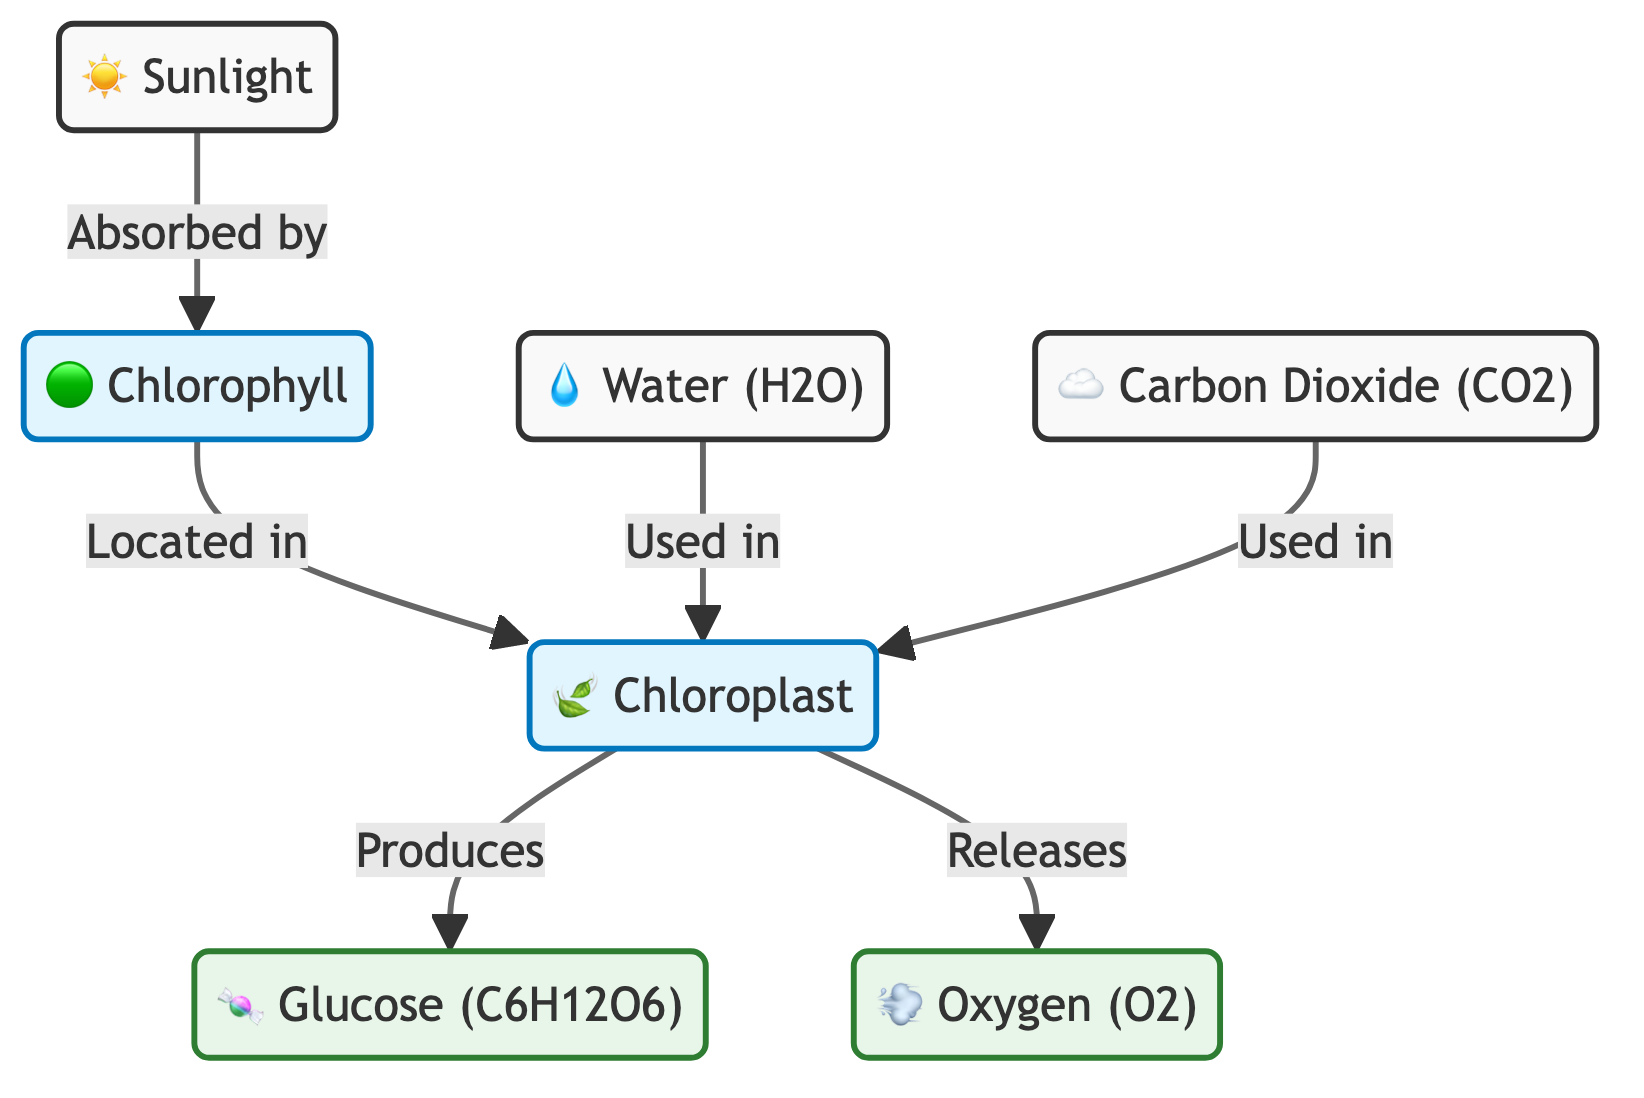What is produced in the chloroplast? The diagram states that the chloroplast produces glucose and releases oxygen, indicating that these are the outputs of the chloroplast. The term "produces" leads directly to "glucose" as one of the products.
Answer: Glucose Where is chlorophyll located? According to the diagram, chlorophyll is located in the chloroplast, which is explicitly mentioned in the connection that indicates its location.
Answer: Chloroplast How many different inputs are used in the chloroplast? The diagram shows two inputs used in the chloroplast: water and carbon dioxide. By identifying the specific nodes that lead into the chloroplast, we find there are two.
Answer: Two What role does sunlight play in photosynthesis? The diagram indicates that sunlight is absorbed by chlorophyll, which is a crucial step in the photosynthesis process, showing its importance in initiating the reaction.
Answer: Absorbed by chlorophyll Which gas is released as a byproduct of the process? The diagram clearly indicates that oxygen is released from the chloroplast as a byproduct of photosynthesis, marking it as one of the outputs of the process.
Answer: Oxygen Which two materials are combined in chloroplasts? The diagram highlights that water and carbon dioxide are both used in the chloroplasts, combined to produce glucose and oxygen during photosynthesis.
Answer: Water and carbon dioxide What is the function of chlorophyll? The diagram indicates that chlorophyll's function is to absorb sunlight, which is essential for the photosynthesis process to occur in plants.
Answer: Absorb sunlight How many products are listed in the diagram? The diagram identifies two products of photosynthesis, glucose and oxygen, emphasizing the outputs generated from the chloroplast during the process.
Answer: Two 